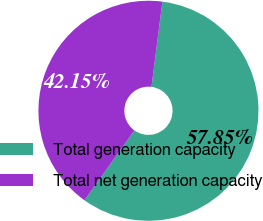<chart> <loc_0><loc_0><loc_500><loc_500><pie_chart><fcel>Total generation capacity<fcel>Total net generation capacity<nl><fcel>57.85%<fcel>42.15%<nl></chart> 